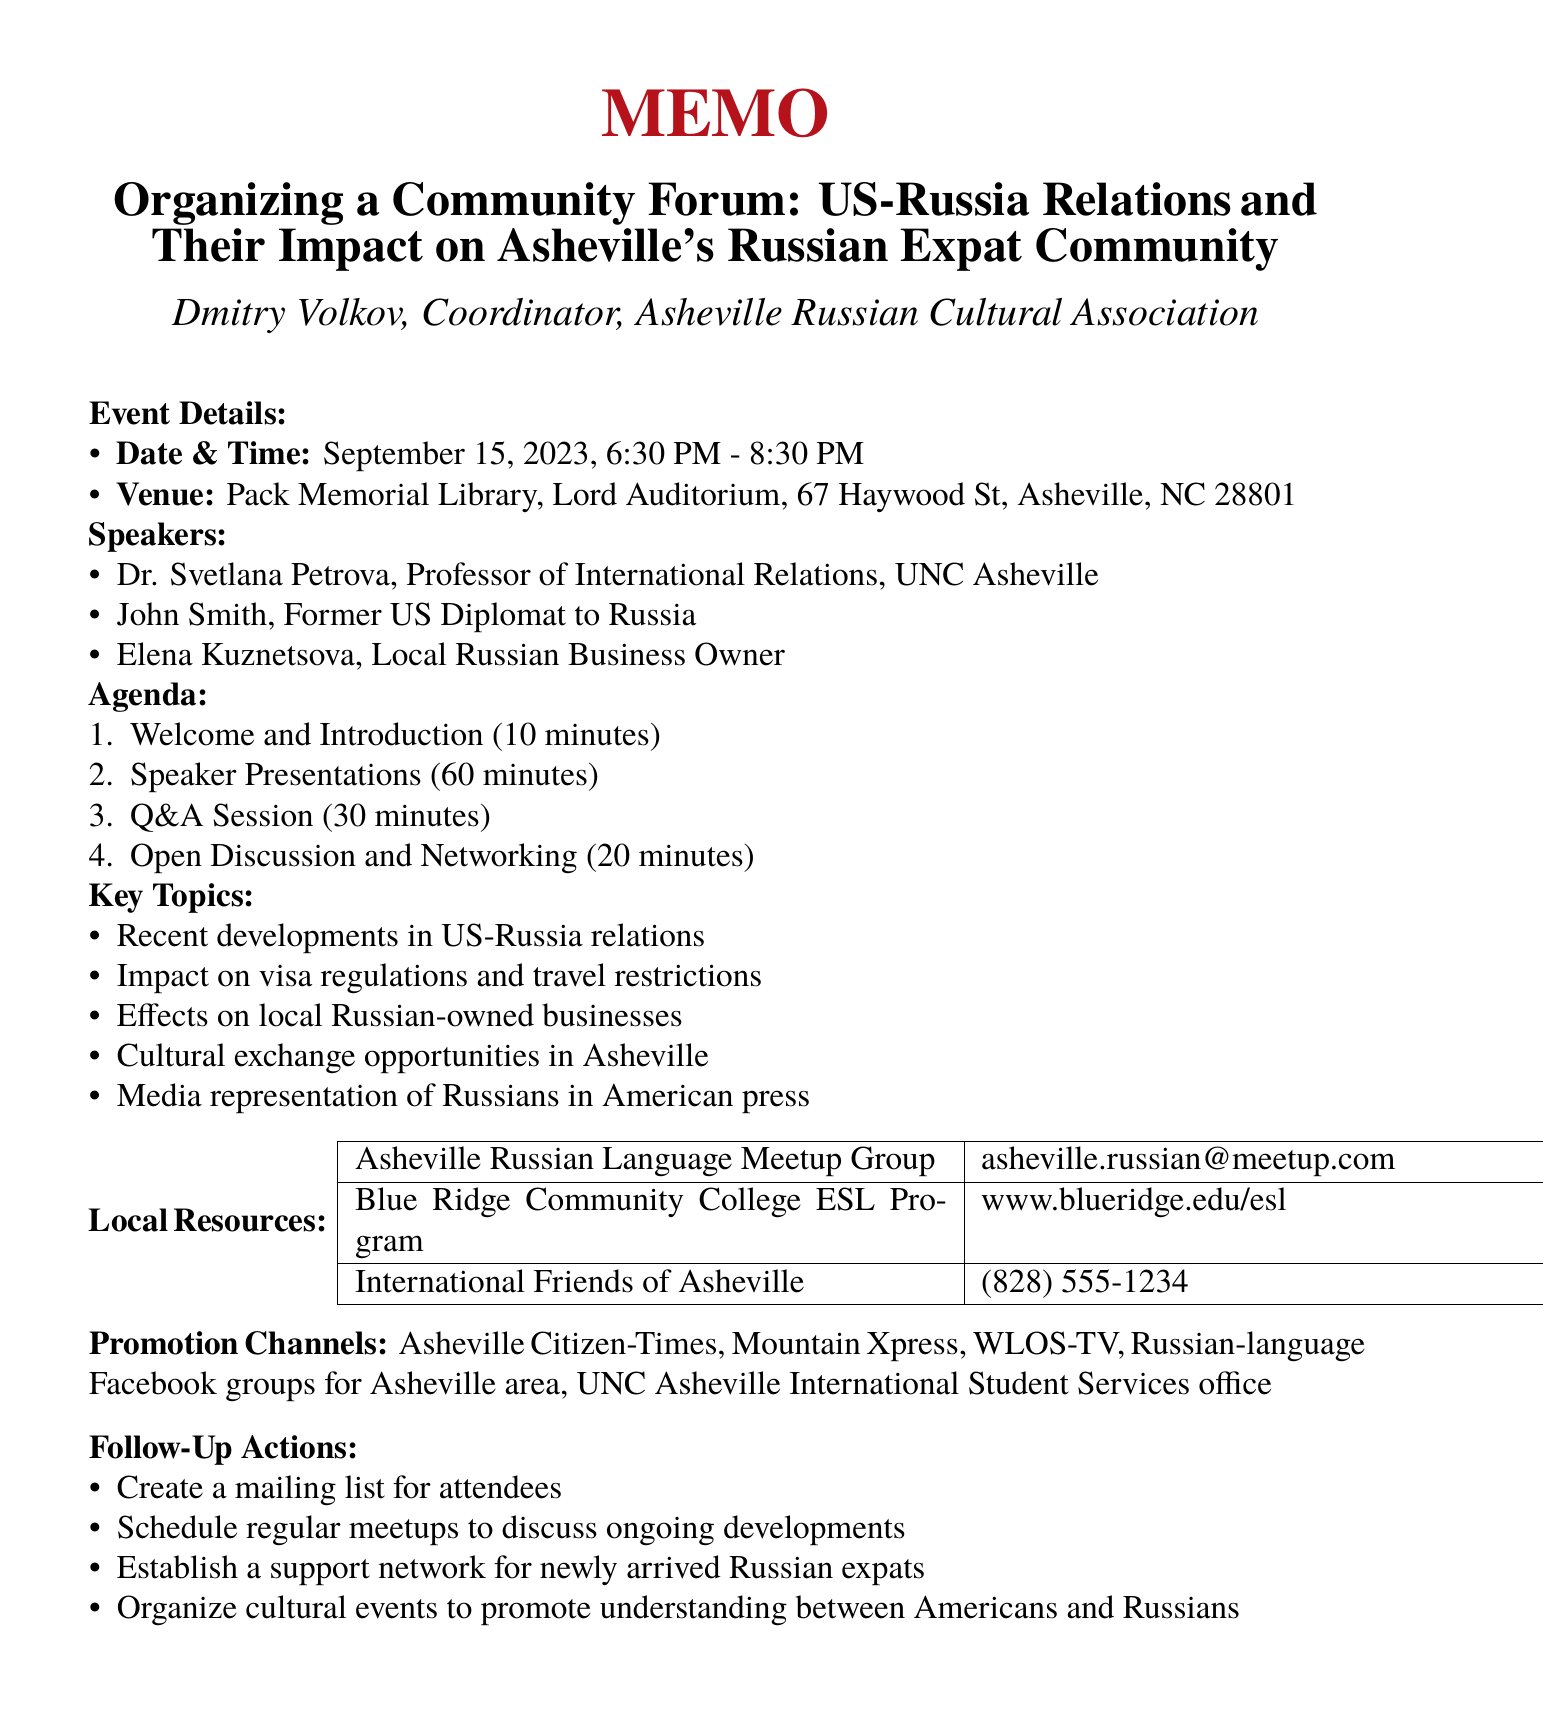what is the date of the forum? The date of the forum is specified in the event details of the memo.
Answer: September 15, 2023 who is the main organizer of the event? The memo lists Dmitry Volkov as the coordinator, which indicates his role in organizing the event.
Answer: Dmitry Volkov how long is the Q&A session planned to last? The duration of the Q&A session is mentioned in the agenda section of the memo.
Answer: 30 minutes which venue is hosting the forum? The venue is clearly stated in the event details section of the memo.
Answer: Pack Memorial Library, Lord Auditorium what is one of the key topics of discussion? Multiple key topics are listed; mentioning any one of them answers the question.
Answer: Recent developments in US-Russia relations who is a speaker with a business background? The memo lists speakers and their backgrounds, so this can be deduced from that information.
Answer: Elena Kuznetsova how many speakers are scheduled for the forum? The memo outlines three speakers, which is the total number scheduled for the event.
Answer: Three which group can be contacted for local Russian language resources? The local resource section in the memo contains contact information for relevant local groups.
Answer: Asheville Russian Language Meetup Group what is one action planned for follow-up after the event? The follow-up actions are detailed at the end of the memo; any action can provide an answer.
Answer: Create a mailing list for attendees 